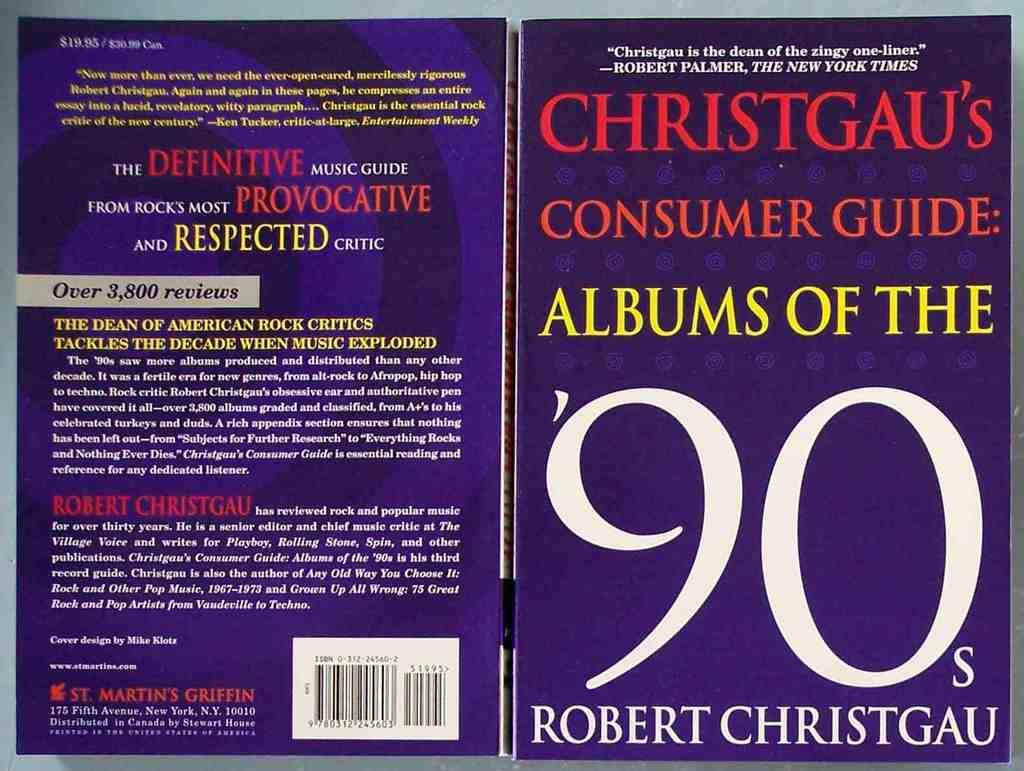<image>
Offer a succinct explanation of the picture presented. The front and back cover to the book Christgau's consumer guide: Albums of the 90's. 